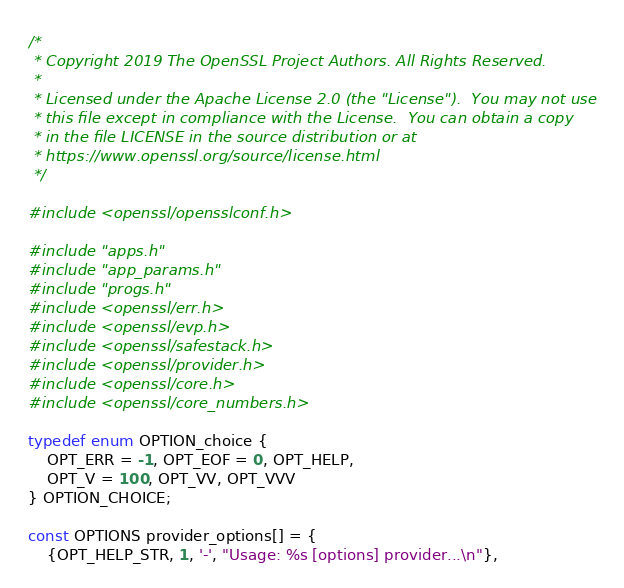<code> <loc_0><loc_0><loc_500><loc_500><_C_>/*
 * Copyright 2019 The OpenSSL Project Authors. All Rights Reserved.
 *
 * Licensed under the Apache License 2.0 (the "License").  You may not use
 * this file except in compliance with the License.  You can obtain a copy
 * in the file LICENSE in the source distribution or at
 * https://www.openssl.org/source/license.html
 */

#include <openssl/opensslconf.h>

#include "apps.h"
#include "app_params.h"
#include "progs.h"
#include <openssl/err.h>
#include <openssl/evp.h>
#include <openssl/safestack.h>
#include <openssl/provider.h>
#include <openssl/core.h>
#include <openssl/core_numbers.h>

typedef enum OPTION_choice {
    OPT_ERR = -1, OPT_EOF = 0, OPT_HELP,
    OPT_V = 100, OPT_VV, OPT_VVV
} OPTION_CHOICE;

const OPTIONS provider_options[] = {
    {OPT_HELP_STR, 1, '-', "Usage: %s [options] provider...\n"},</code> 